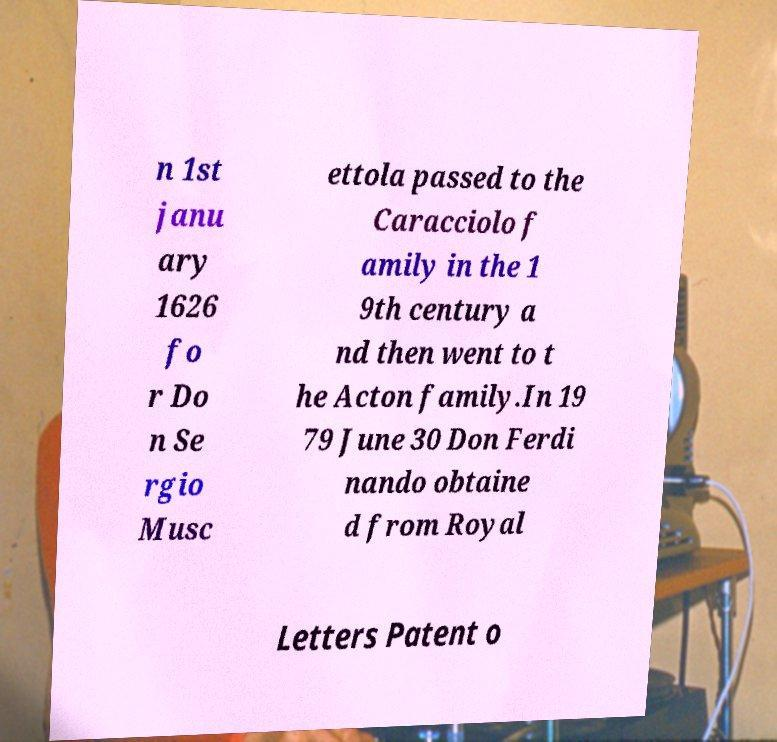Could you assist in decoding the text presented in this image and type it out clearly? n 1st janu ary 1626 fo r Do n Se rgio Musc ettola passed to the Caracciolo f amily in the 1 9th century a nd then went to t he Acton family.In 19 79 June 30 Don Ferdi nando obtaine d from Royal Letters Patent o 